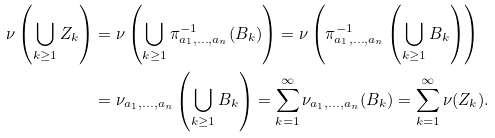<formula> <loc_0><loc_0><loc_500><loc_500>\nu \left ( \bigcup _ { k \geq 1 } Z _ { k } \right ) & = \nu \left ( \bigcup _ { k \geq 1 } \pi _ { a _ { 1 } , \dots , a _ { n } } ^ { - 1 } ( B _ { k } ) \right ) = \nu \left ( \pi _ { a _ { 1 } , \dots , a _ { n } } ^ { - 1 } \left ( \bigcup _ { k \geq 1 } B _ { k } \right ) \right ) \\ & = \nu _ { a _ { 1 } , \dots , a _ { n } } \left ( \bigcup _ { k \geq 1 } B _ { k } \right ) = \sum _ { k = 1 } ^ { \infty } \nu _ { a _ { 1 } , \dots , a _ { n } } ( B _ { k } ) = \sum _ { k = 1 } ^ { \infty } \nu ( Z _ { k } ) .</formula> 